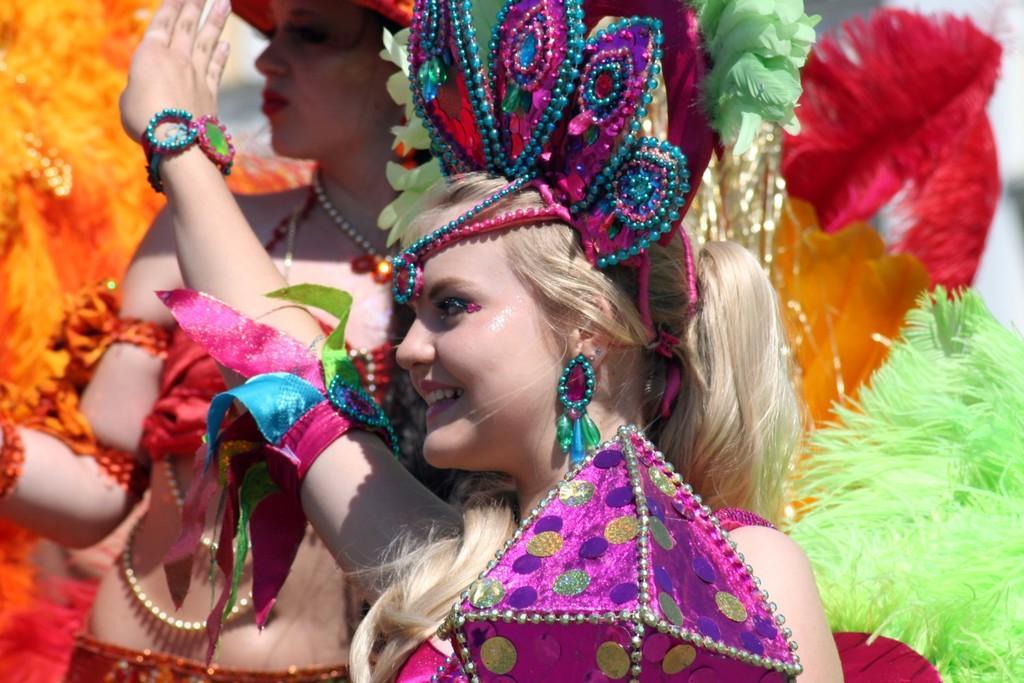Could you give a brief overview of what you see in this image? This picture describes about few people, they wearing costumes, in the middle of the image we can see a woman, she is smiling. 